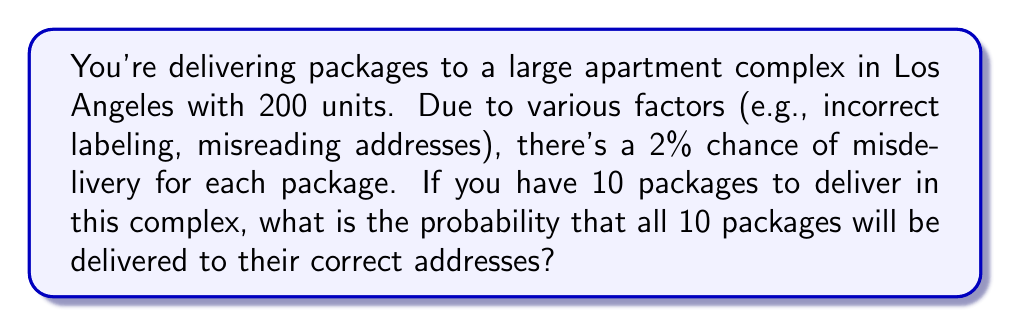Can you answer this question? Let's approach this step-by-step:

1) First, we need to calculate the probability of a single package being delivered correctly. If there's a 2% chance of misdelivery, then the probability of correct delivery is:

   $1 - 0.02 = 0.98$ or $98\%$

2) Now, we need to find the probability of all 10 packages being delivered correctly. This is a case of independent events, where the success of one delivery doesn't affect the others.

3) When we have multiple independent events and we want all of them to occur, we multiply the individual probabilities:

   $P(\text{all correct}) = 0.98 \times 0.98 \times ... \times 0.98$ (10 times)

4) This can be written as an exponent:

   $P(\text{all correct}) = (0.98)^{10}$

5) Let's calculate this:

   $$(0.98)^{10} = 0.8179$$

6) Converting to a percentage:

   $0.8179 \times 100\% = 81.79\%$

Therefore, the probability that all 10 packages will be delivered to their correct addresses is approximately 81.79%.
Answer: $81.79\%$ 